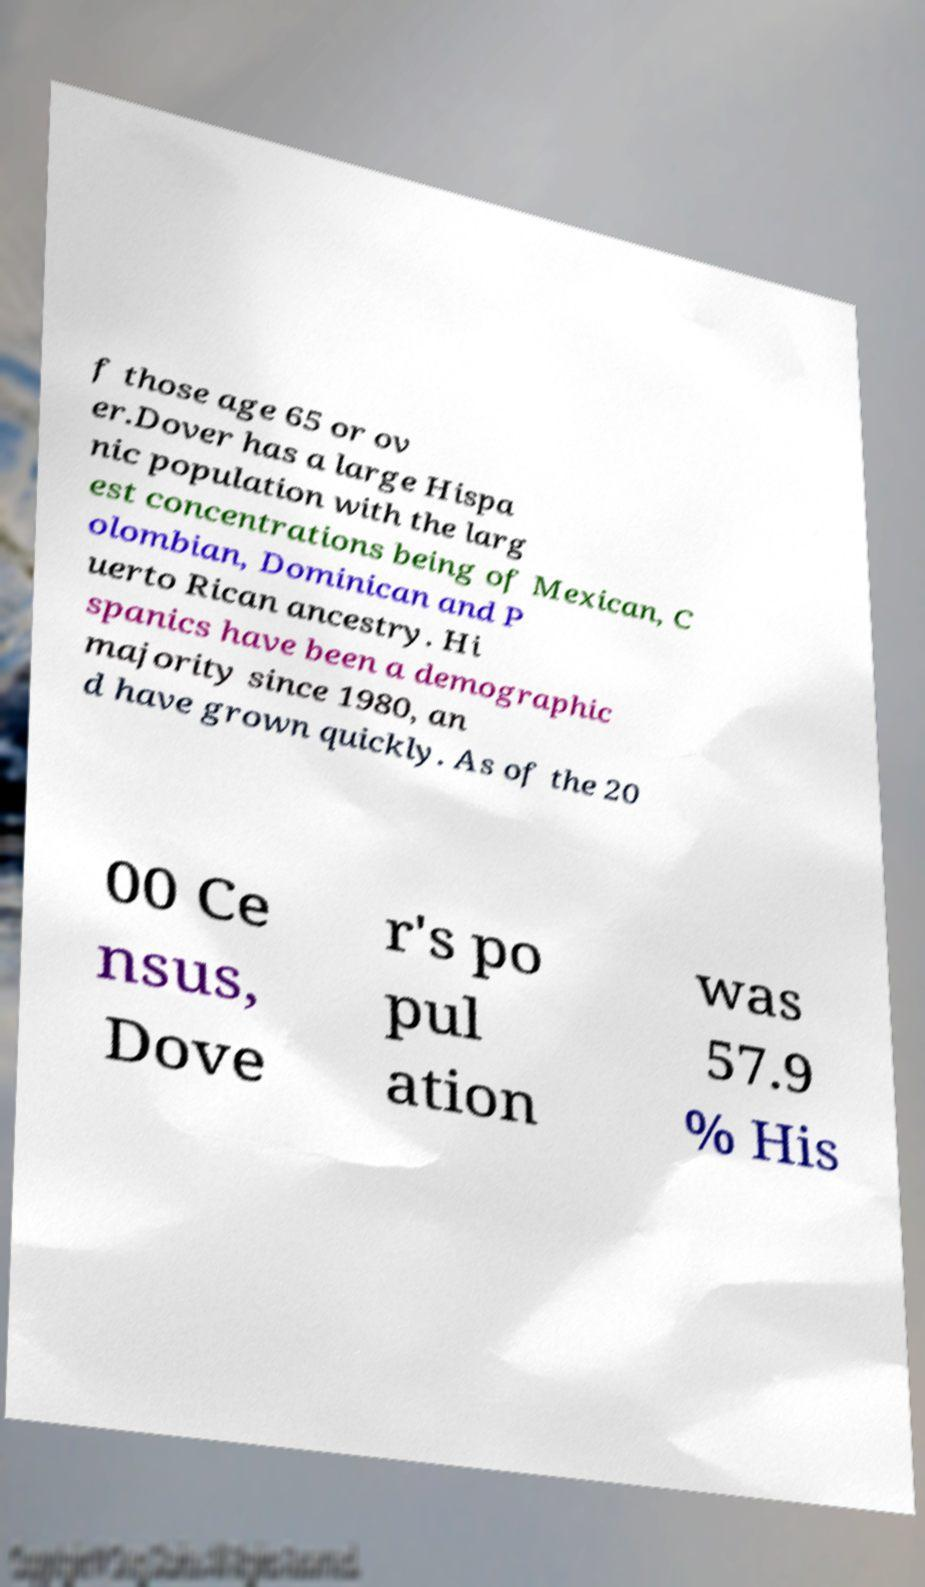I need the written content from this picture converted into text. Can you do that? f those age 65 or ov er.Dover has a large Hispa nic population with the larg est concentrations being of Mexican, C olombian, Dominican and P uerto Rican ancestry. Hi spanics have been a demographic majority since 1980, an d have grown quickly. As of the 20 00 Ce nsus, Dove r's po pul ation was 57.9 % His 